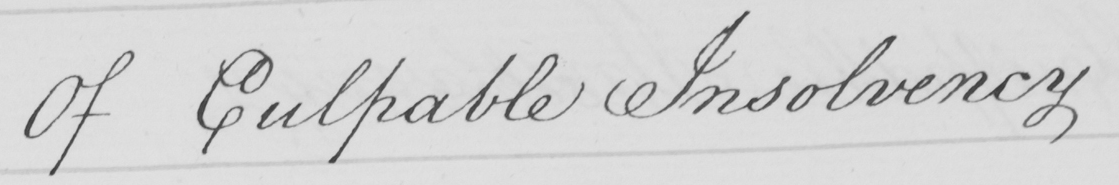Please transcribe the handwritten text in this image. Of Culpable Insolvency 